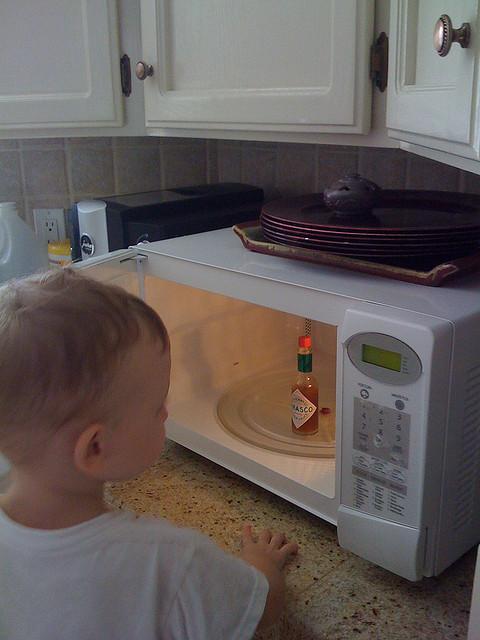How many people are in the photo?
Give a very brief answer. 1. 